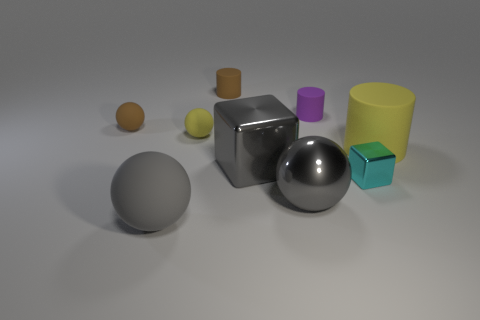Subtract all gray metallic spheres. How many spheres are left? 3 Subtract all yellow spheres. How many spheres are left? 3 Add 1 big shiny blocks. How many objects exist? 10 Add 3 big metal spheres. How many big metal spheres are left? 4 Add 7 gray metal cubes. How many gray metal cubes exist? 8 Subtract 0 red balls. How many objects are left? 9 Subtract all balls. How many objects are left? 5 Subtract 3 spheres. How many spheres are left? 1 Subtract all cyan cylinders. Subtract all purple balls. How many cylinders are left? 3 Subtract all green cubes. How many purple cylinders are left? 1 